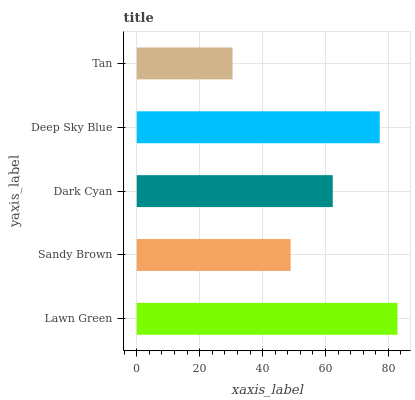Is Tan the minimum?
Answer yes or no. Yes. Is Lawn Green the maximum?
Answer yes or no. Yes. Is Sandy Brown the minimum?
Answer yes or no. No. Is Sandy Brown the maximum?
Answer yes or no. No. Is Lawn Green greater than Sandy Brown?
Answer yes or no. Yes. Is Sandy Brown less than Lawn Green?
Answer yes or no. Yes. Is Sandy Brown greater than Lawn Green?
Answer yes or no. No. Is Lawn Green less than Sandy Brown?
Answer yes or no. No. Is Dark Cyan the high median?
Answer yes or no. Yes. Is Dark Cyan the low median?
Answer yes or no. Yes. Is Tan the high median?
Answer yes or no. No. Is Sandy Brown the low median?
Answer yes or no. No. 